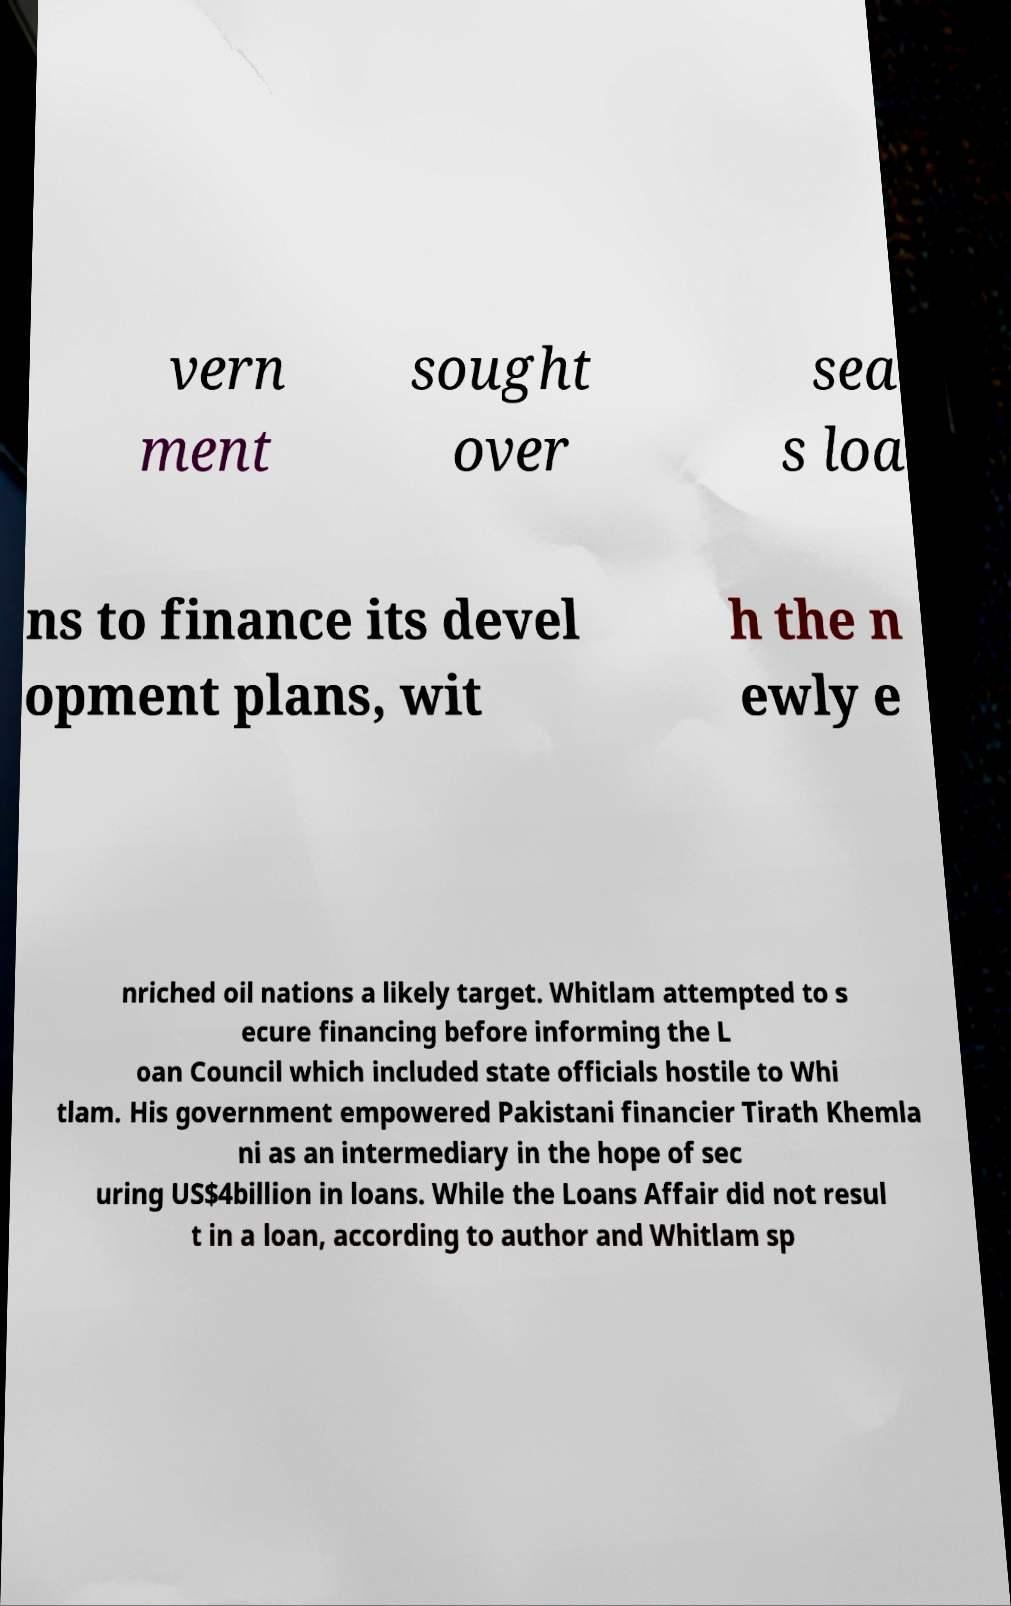Could you assist in decoding the text presented in this image and type it out clearly? vern ment sought over sea s loa ns to finance its devel opment plans, wit h the n ewly e nriched oil nations a likely target. Whitlam attempted to s ecure financing before informing the L oan Council which included state officials hostile to Whi tlam. His government empowered Pakistani financier Tirath Khemla ni as an intermediary in the hope of sec uring US$4billion in loans. While the Loans Affair did not resul t in a loan, according to author and Whitlam sp 